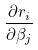<formula> <loc_0><loc_0><loc_500><loc_500>\frac { \partial r _ { i } } { \partial \beta _ { j } }</formula> 